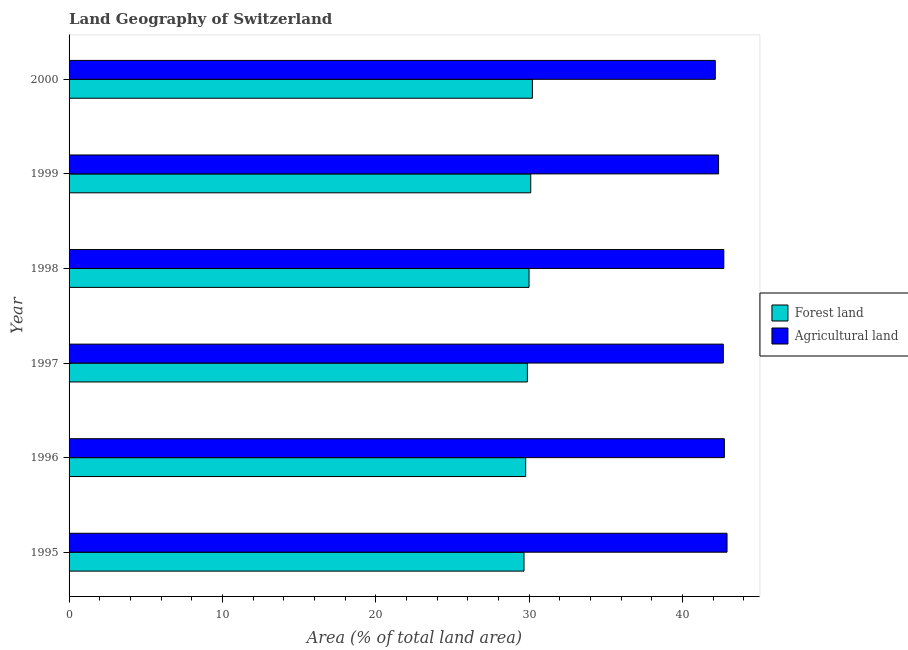How many bars are there on the 6th tick from the bottom?
Make the answer very short. 2. What is the label of the 3rd group of bars from the top?
Your answer should be very brief. 1998. What is the percentage of land area under agriculture in 1995?
Ensure brevity in your answer.  42.9. Across all years, what is the maximum percentage of land area under agriculture?
Offer a very short reply. 42.9. Across all years, what is the minimum percentage of land area under forests?
Keep it short and to the point. 29.66. In which year was the percentage of land area under forests maximum?
Keep it short and to the point. 2000. In which year was the percentage of land area under forests minimum?
Ensure brevity in your answer.  1995. What is the total percentage of land area under agriculture in the graph?
Make the answer very short. 255.45. What is the difference between the percentage of land area under agriculture in 1998 and that in 2000?
Your answer should be very brief. 0.56. What is the difference between the percentage of land area under agriculture in 1998 and the percentage of land area under forests in 1996?
Your answer should be compact. 12.92. What is the average percentage of land area under forests per year?
Offer a terse response. 29.94. In the year 1995, what is the difference between the percentage of land area under forests and percentage of land area under agriculture?
Keep it short and to the point. -13.24. Is the percentage of land area under agriculture in 1997 less than that in 2000?
Keep it short and to the point. No. What is the difference between the highest and the second highest percentage of land area under forests?
Provide a succinct answer. 0.11. What is the difference between the highest and the lowest percentage of land area under forests?
Your answer should be compact. 0.55. In how many years, is the percentage of land area under forests greater than the average percentage of land area under forests taken over all years?
Keep it short and to the point. 3. Is the sum of the percentage of land area under agriculture in 1996 and 1998 greater than the maximum percentage of land area under forests across all years?
Give a very brief answer. Yes. What does the 2nd bar from the top in 1998 represents?
Provide a short and direct response. Forest land. What does the 1st bar from the bottom in 1999 represents?
Provide a succinct answer. Forest land. How many bars are there?
Provide a succinct answer. 12. How many years are there in the graph?
Make the answer very short. 6. Are the values on the major ticks of X-axis written in scientific E-notation?
Provide a succinct answer. No. How are the legend labels stacked?
Provide a succinct answer. Vertical. What is the title of the graph?
Offer a very short reply. Land Geography of Switzerland. What is the label or title of the X-axis?
Your response must be concise. Area (% of total land area). What is the Area (% of total land area) of Forest land in 1995?
Offer a very short reply. 29.66. What is the Area (% of total land area) in Agricultural land in 1995?
Provide a short and direct response. 42.9. What is the Area (% of total land area) of Forest land in 1996?
Offer a terse response. 29.77. What is the Area (% of total land area) of Agricultural land in 1996?
Make the answer very short. 42.72. What is the Area (% of total land area) of Forest land in 1997?
Keep it short and to the point. 29.88. What is the Area (% of total land area) of Agricultural land in 1997?
Your response must be concise. 42.66. What is the Area (% of total land area) of Forest land in 1998?
Keep it short and to the point. 29.99. What is the Area (% of total land area) in Agricultural land in 1998?
Provide a succinct answer. 42.69. What is the Area (% of total land area) of Forest land in 1999?
Provide a short and direct response. 30.1. What is the Area (% of total land area) in Agricultural land in 1999?
Offer a terse response. 42.35. What is the Area (% of total land area) of Forest land in 2000?
Keep it short and to the point. 30.21. What is the Area (% of total land area) in Agricultural land in 2000?
Your answer should be compact. 42.13. Across all years, what is the maximum Area (% of total land area) in Forest land?
Offer a terse response. 30.21. Across all years, what is the maximum Area (% of total land area) in Agricultural land?
Offer a very short reply. 42.9. Across all years, what is the minimum Area (% of total land area) in Forest land?
Provide a succinct answer. 29.66. Across all years, what is the minimum Area (% of total land area) in Agricultural land?
Keep it short and to the point. 42.13. What is the total Area (% of total land area) of Forest land in the graph?
Your response must be concise. 179.61. What is the total Area (% of total land area) in Agricultural land in the graph?
Make the answer very short. 255.45. What is the difference between the Area (% of total land area) of Forest land in 1995 and that in 1996?
Offer a terse response. -0.11. What is the difference between the Area (% of total land area) of Agricultural land in 1995 and that in 1996?
Offer a very short reply. 0.17. What is the difference between the Area (% of total land area) of Forest land in 1995 and that in 1997?
Make the answer very short. -0.22. What is the difference between the Area (% of total land area) of Agricultural land in 1995 and that in 1997?
Provide a short and direct response. 0.24. What is the difference between the Area (% of total land area) of Forest land in 1995 and that in 1998?
Your response must be concise. -0.33. What is the difference between the Area (% of total land area) of Agricultural land in 1995 and that in 1998?
Your answer should be very brief. 0.21. What is the difference between the Area (% of total land area) in Forest land in 1995 and that in 1999?
Offer a terse response. -0.44. What is the difference between the Area (% of total land area) in Agricultural land in 1995 and that in 1999?
Give a very brief answer. 0.55. What is the difference between the Area (% of total land area) of Forest land in 1995 and that in 2000?
Provide a short and direct response. -0.55. What is the difference between the Area (% of total land area) in Agricultural land in 1995 and that in 2000?
Offer a very short reply. 0.77. What is the difference between the Area (% of total land area) in Forest land in 1996 and that in 1997?
Offer a very short reply. -0.11. What is the difference between the Area (% of total land area) of Agricultural land in 1996 and that in 1997?
Keep it short and to the point. 0.07. What is the difference between the Area (% of total land area) in Forest land in 1996 and that in 1998?
Your answer should be very brief. -0.22. What is the difference between the Area (% of total land area) in Agricultural land in 1996 and that in 1998?
Make the answer very short. 0.04. What is the difference between the Area (% of total land area) in Forest land in 1996 and that in 1999?
Offer a terse response. -0.33. What is the difference between the Area (% of total land area) of Agricultural land in 1996 and that in 1999?
Offer a terse response. 0.38. What is the difference between the Area (% of total land area) of Forest land in 1996 and that in 2000?
Your answer should be compact. -0.44. What is the difference between the Area (% of total land area) of Agricultural land in 1996 and that in 2000?
Offer a terse response. 0.59. What is the difference between the Area (% of total land area) of Forest land in 1997 and that in 1998?
Provide a succinct answer. -0.11. What is the difference between the Area (% of total land area) in Agricultural land in 1997 and that in 1998?
Your response must be concise. -0.03. What is the difference between the Area (% of total land area) of Forest land in 1997 and that in 1999?
Provide a succinct answer. -0.22. What is the difference between the Area (% of total land area) in Agricultural land in 1997 and that in 1999?
Give a very brief answer. 0.31. What is the difference between the Area (% of total land area) in Forest land in 1997 and that in 2000?
Offer a terse response. -0.33. What is the difference between the Area (% of total land area) in Agricultural land in 1997 and that in 2000?
Your answer should be compact. 0.52. What is the difference between the Area (% of total land area) in Forest land in 1998 and that in 1999?
Your answer should be compact. -0.11. What is the difference between the Area (% of total land area) of Agricultural land in 1998 and that in 1999?
Offer a terse response. 0.34. What is the difference between the Area (% of total land area) of Forest land in 1998 and that in 2000?
Provide a succinct answer. -0.22. What is the difference between the Area (% of total land area) in Agricultural land in 1998 and that in 2000?
Keep it short and to the point. 0.56. What is the difference between the Area (% of total land area) in Forest land in 1999 and that in 2000?
Your answer should be very brief. -0.11. What is the difference between the Area (% of total land area) in Agricultural land in 1999 and that in 2000?
Give a very brief answer. 0.21. What is the difference between the Area (% of total land area) in Forest land in 1995 and the Area (% of total land area) in Agricultural land in 1996?
Offer a very short reply. -13.06. What is the difference between the Area (% of total land area) in Forest land in 1995 and the Area (% of total land area) in Agricultural land in 1997?
Provide a short and direct response. -12.99. What is the difference between the Area (% of total land area) in Forest land in 1995 and the Area (% of total land area) in Agricultural land in 1998?
Your answer should be compact. -13.03. What is the difference between the Area (% of total land area) in Forest land in 1995 and the Area (% of total land area) in Agricultural land in 1999?
Provide a succinct answer. -12.69. What is the difference between the Area (% of total land area) in Forest land in 1995 and the Area (% of total land area) in Agricultural land in 2000?
Your answer should be very brief. -12.47. What is the difference between the Area (% of total land area) in Forest land in 1996 and the Area (% of total land area) in Agricultural land in 1997?
Your answer should be compact. -12.88. What is the difference between the Area (% of total land area) of Forest land in 1996 and the Area (% of total land area) of Agricultural land in 1998?
Give a very brief answer. -12.92. What is the difference between the Area (% of total land area) in Forest land in 1996 and the Area (% of total land area) in Agricultural land in 1999?
Provide a short and direct response. -12.58. What is the difference between the Area (% of total land area) of Forest land in 1996 and the Area (% of total land area) of Agricultural land in 2000?
Your response must be concise. -12.36. What is the difference between the Area (% of total land area) in Forest land in 1997 and the Area (% of total land area) in Agricultural land in 1998?
Your response must be concise. -12.81. What is the difference between the Area (% of total land area) of Forest land in 1997 and the Area (% of total land area) of Agricultural land in 1999?
Offer a very short reply. -12.47. What is the difference between the Area (% of total land area) in Forest land in 1997 and the Area (% of total land area) in Agricultural land in 2000?
Offer a very short reply. -12.25. What is the difference between the Area (% of total land area) of Forest land in 1998 and the Area (% of total land area) of Agricultural land in 1999?
Your answer should be compact. -12.36. What is the difference between the Area (% of total land area) in Forest land in 1998 and the Area (% of total land area) in Agricultural land in 2000?
Provide a short and direct response. -12.14. What is the difference between the Area (% of total land area) of Forest land in 1999 and the Area (% of total land area) of Agricultural land in 2000?
Give a very brief answer. -12.03. What is the average Area (% of total land area) of Forest land per year?
Offer a very short reply. 29.94. What is the average Area (% of total land area) of Agricultural land per year?
Ensure brevity in your answer.  42.57. In the year 1995, what is the difference between the Area (% of total land area) in Forest land and Area (% of total land area) in Agricultural land?
Offer a very short reply. -13.24. In the year 1996, what is the difference between the Area (% of total land area) of Forest land and Area (% of total land area) of Agricultural land?
Your answer should be very brief. -12.95. In the year 1997, what is the difference between the Area (% of total land area) in Forest land and Area (% of total land area) in Agricultural land?
Offer a very short reply. -12.78. In the year 1998, what is the difference between the Area (% of total land area) of Forest land and Area (% of total land area) of Agricultural land?
Your answer should be very brief. -12.7. In the year 1999, what is the difference between the Area (% of total land area) of Forest land and Area (% of total land area) of Agricultural land?
Offer a terse response. -12.25. In the year 2000, what is the difference between the Area (% of total land area) in Forest land and Area (% of total land area) in Agricultural land?
Your response must be concise. -11.92. What is the ratio of the Area (% of total land area) of Forest land in 1995 to that in 1996?
Provide a short and direct response. 1. What is the ratio of the Area (% of total land area) of Agricultural land in 1995 to that in 1997?
Provide a short and direct response. 1.01. What is the ratio of the Area (% of total land area) of Forest land in 1995 to that in 1999?
Offer a terse response. 0.99. What is the ratio of the Area (% of total land area) in Agricultural land in 1995 to that in 1999?
Your answer should be very brief. 1.01. What is the ratio of the Area (% of total land area) in Forest land in 1995 to that in 2000?
Ensure brevity in your answer.  0.98. What is the ratio of the Area (% of total land area) of Agricultural land in 1995 to that in 2000?
Keep it short and to the point. 1.02. What is the ratio of the Area (% of total land area) of Forest land in 1996 to that in 1998?
Keep it short and to the point. 0.99. What is the ratio of the Area (% of total land area) of Agricultural land in 1996 to that in 1998?
Offer a very short reply. 1. What is the ratio of the Area (% of total land area) in Agricultural land in 1996 to that in 1999?
Offer a terse response. 1.01. What is the ratio of the Area (% of total land area) of Forest land in 1996 to that in 2000?
Offer a very short reply. 0.99. What is the ratio of the Area (% of total land area) in Agricultural land in 1996 to that in 2000?
Give a very brief answer. 1.01. What is the ratio of the Area (% of total land area) of Forest land in 1997 to that in 1998?
Give a very brief answer. 1. What is the ratio of the Area (% of total land area) of Agricultural land in 1997 to that in 1998?
Make the answer very short. 1. What is the ratio of the Area (% of total land area) in Forest land in 1997 to that in 1999?
Keep it short and to the point. 0.99. What is the ratio of the Area (% of total land area) in Agricultural land in 1997 to that in 1999?
Your answer should be very brief. 1.01. What is the ratio of the Area (% of total land area) of Agricultural land in 1997 to that in 2000?
Offer a terse response. 1.01. What is the ratio of the Area (% of total land area) of Forest land in 1998 to that in 1999?
Keep it short and to the point. 1. What is the ratio of the Area (% of total land area) in Forest land in 1998 to that in 2000?
Provide a short and direct response. 0.99. What is the ratio of the Area (% of total land area) of Agricultural land in 1998 to that in 2000?
Make the answer very short. 1.01. What is the ratio of the Area (% of total land area) of Forest land in 1999 to that in 2000?
Make the answer very short. 1. What is the difference between the highest and the second highest Area (% of total land area) of Forest land?
Provide a succinct answer. 0.11. What is the difference between the highest and the second highest Area (% of total land area) in Agricultural land?
Offer a very short reply. 0.17. What is the difference between the highest and the lowest Area (% of total land area) of Forest land?
Your response must be concise. 0.55. What is the difference between the highest and the lowest Area (% of total land area) in Agricultural land?
Provide a short and direct response. 0.77. 